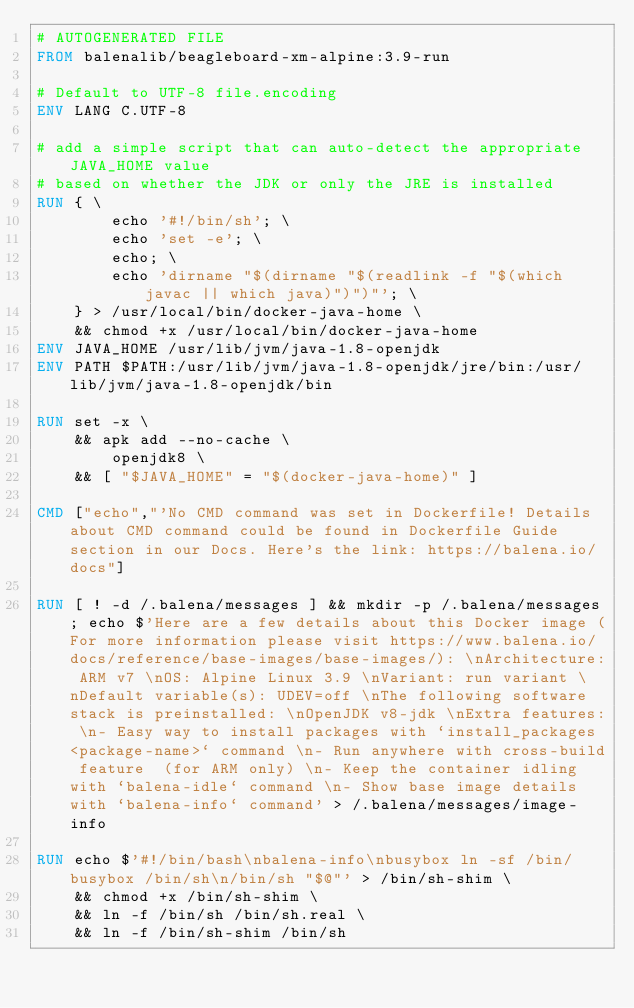<code> <loc_0><loc_0><loc_500><loc_500><_Dockerfile_># AUTOGENERATED FILE
FROM balenalib/beagleboard-xm-alpine:3.9-run

# Default to UTF-8 file.encoding
ENV LANG C.UTF-8

# add a simple script that can auto-detect the appropriate JAVA_HOME value
# based on whether the JDK or only the JRE is installed
RUN { \
		echo '#!/bin/sh'; \
		echo 'set -e'; \
		echo; \
		echo 'dirname "$(dirname "$(readlink -f "$(which javac || which java)")")"'; \
	} > /usr/local/bin/docker-java-home \
	&& chmod +x /usr/local/bin/docker-java-home
ENV JAVA_HOME /usr/lib/jvm/java-1.8-openjdk
ENV PATH $PATH:/usr/lib/jvm/java-1.8-openjdk/jre/bin:/usr/lib/jvm/java-1.8-openjdk/bin

RUN set -x \
	&& apk add --no-cache \
		openjdk8 \
	&& [ "$JAVA_HOME" = "$(docker-java-home)" ]

CMD ["echo","'No CMD command was set in Dockerfile! Details about CMD command could be found in Dockerfile Guide section in our Docs. Here's the link: https://balena.io/docs"]

RUN [ ! -d /.balena/messages ] && mkdir -p /.balena/messages; echo $'Here are a few details about this Docker image (For more information please visit https://www.balena.io/docs/reference/base-images/base-images/): \nArchitecture: ARM v7 \nOS: Alpine Linux 3.9 \nVariant: run variant \nDefault variable(s): UDEV=off \nThe following software stack is preinstalled: \nOpenJDK v8-jdk \nExtra features: \n- Easy way to install packages with `install_packages <package-name>` command \n- Run anywhere with cross-build feature  (for ARM only) \n- Keep the container idling with `balena-idle` command \n- Show base image details with `balena-info` command' > /.balena/messages/image-info

RUN echo $'#!/bin/bash\nbalena-info\nbusybox ln -sf /bin/busybox /bin/sh\n/bin/sh "$@"' > /bin/sh-shim \
	&& chmod +x /bin/sh-shim \
	&& ln -f /bin/sh /bin/sh.real \
	&& ln -f /bin/sh-shim /bin/sh</code> 